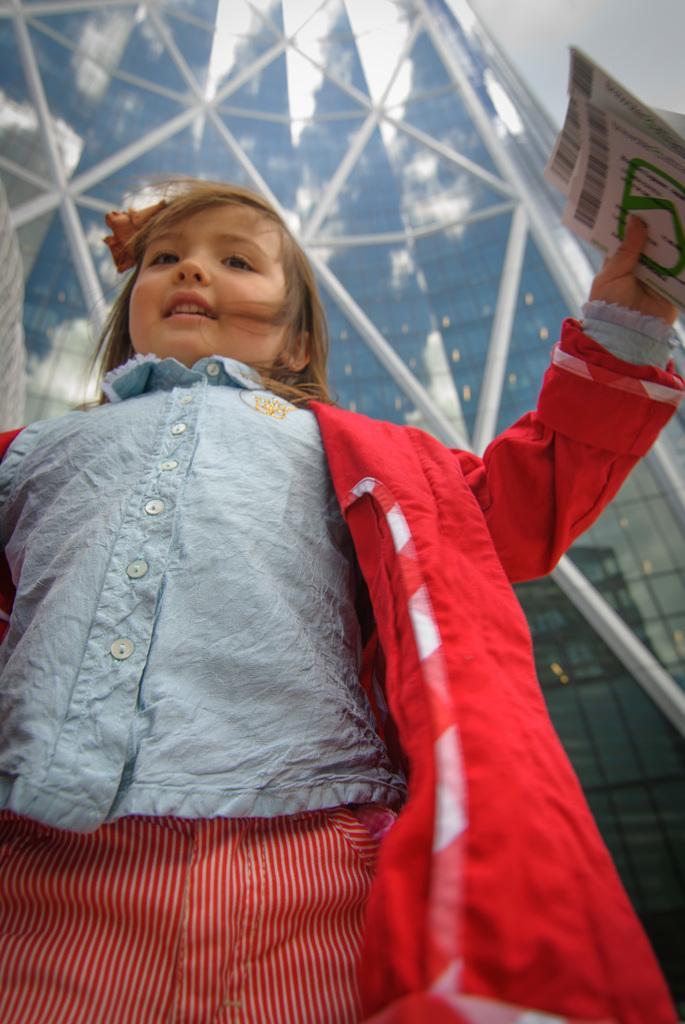How would you summarize this image in a sentence or two? In this image we can see a girl is standing, she is wearing blue shirt and red color coat, holding papers in her hand. Background one building is there. 